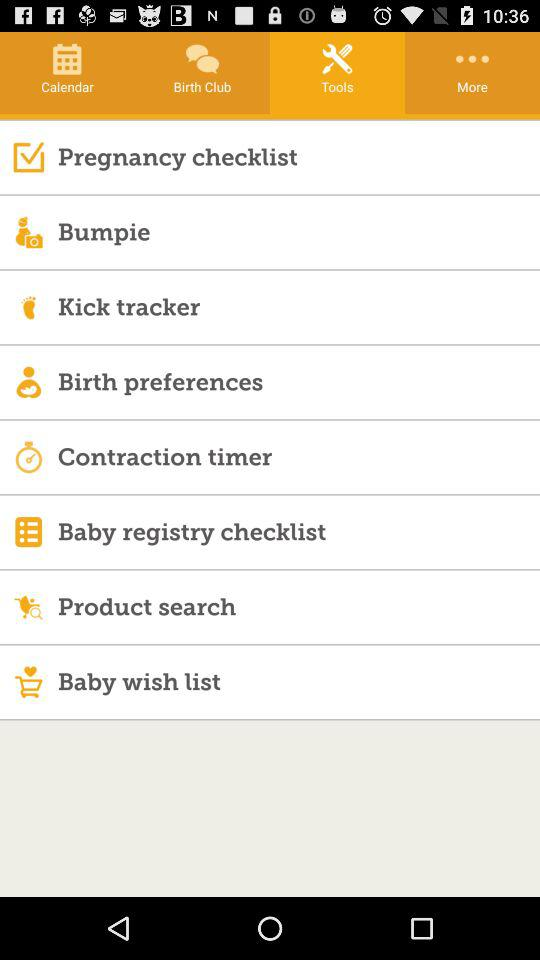What are the options available in tools? The options available in tools are "Pregnancy checklist", "Bumpie", "Kick tracker", "Birth preferences", "Contraction timer", "Baby registry checklist", "Product search" and "Baby wish list". 